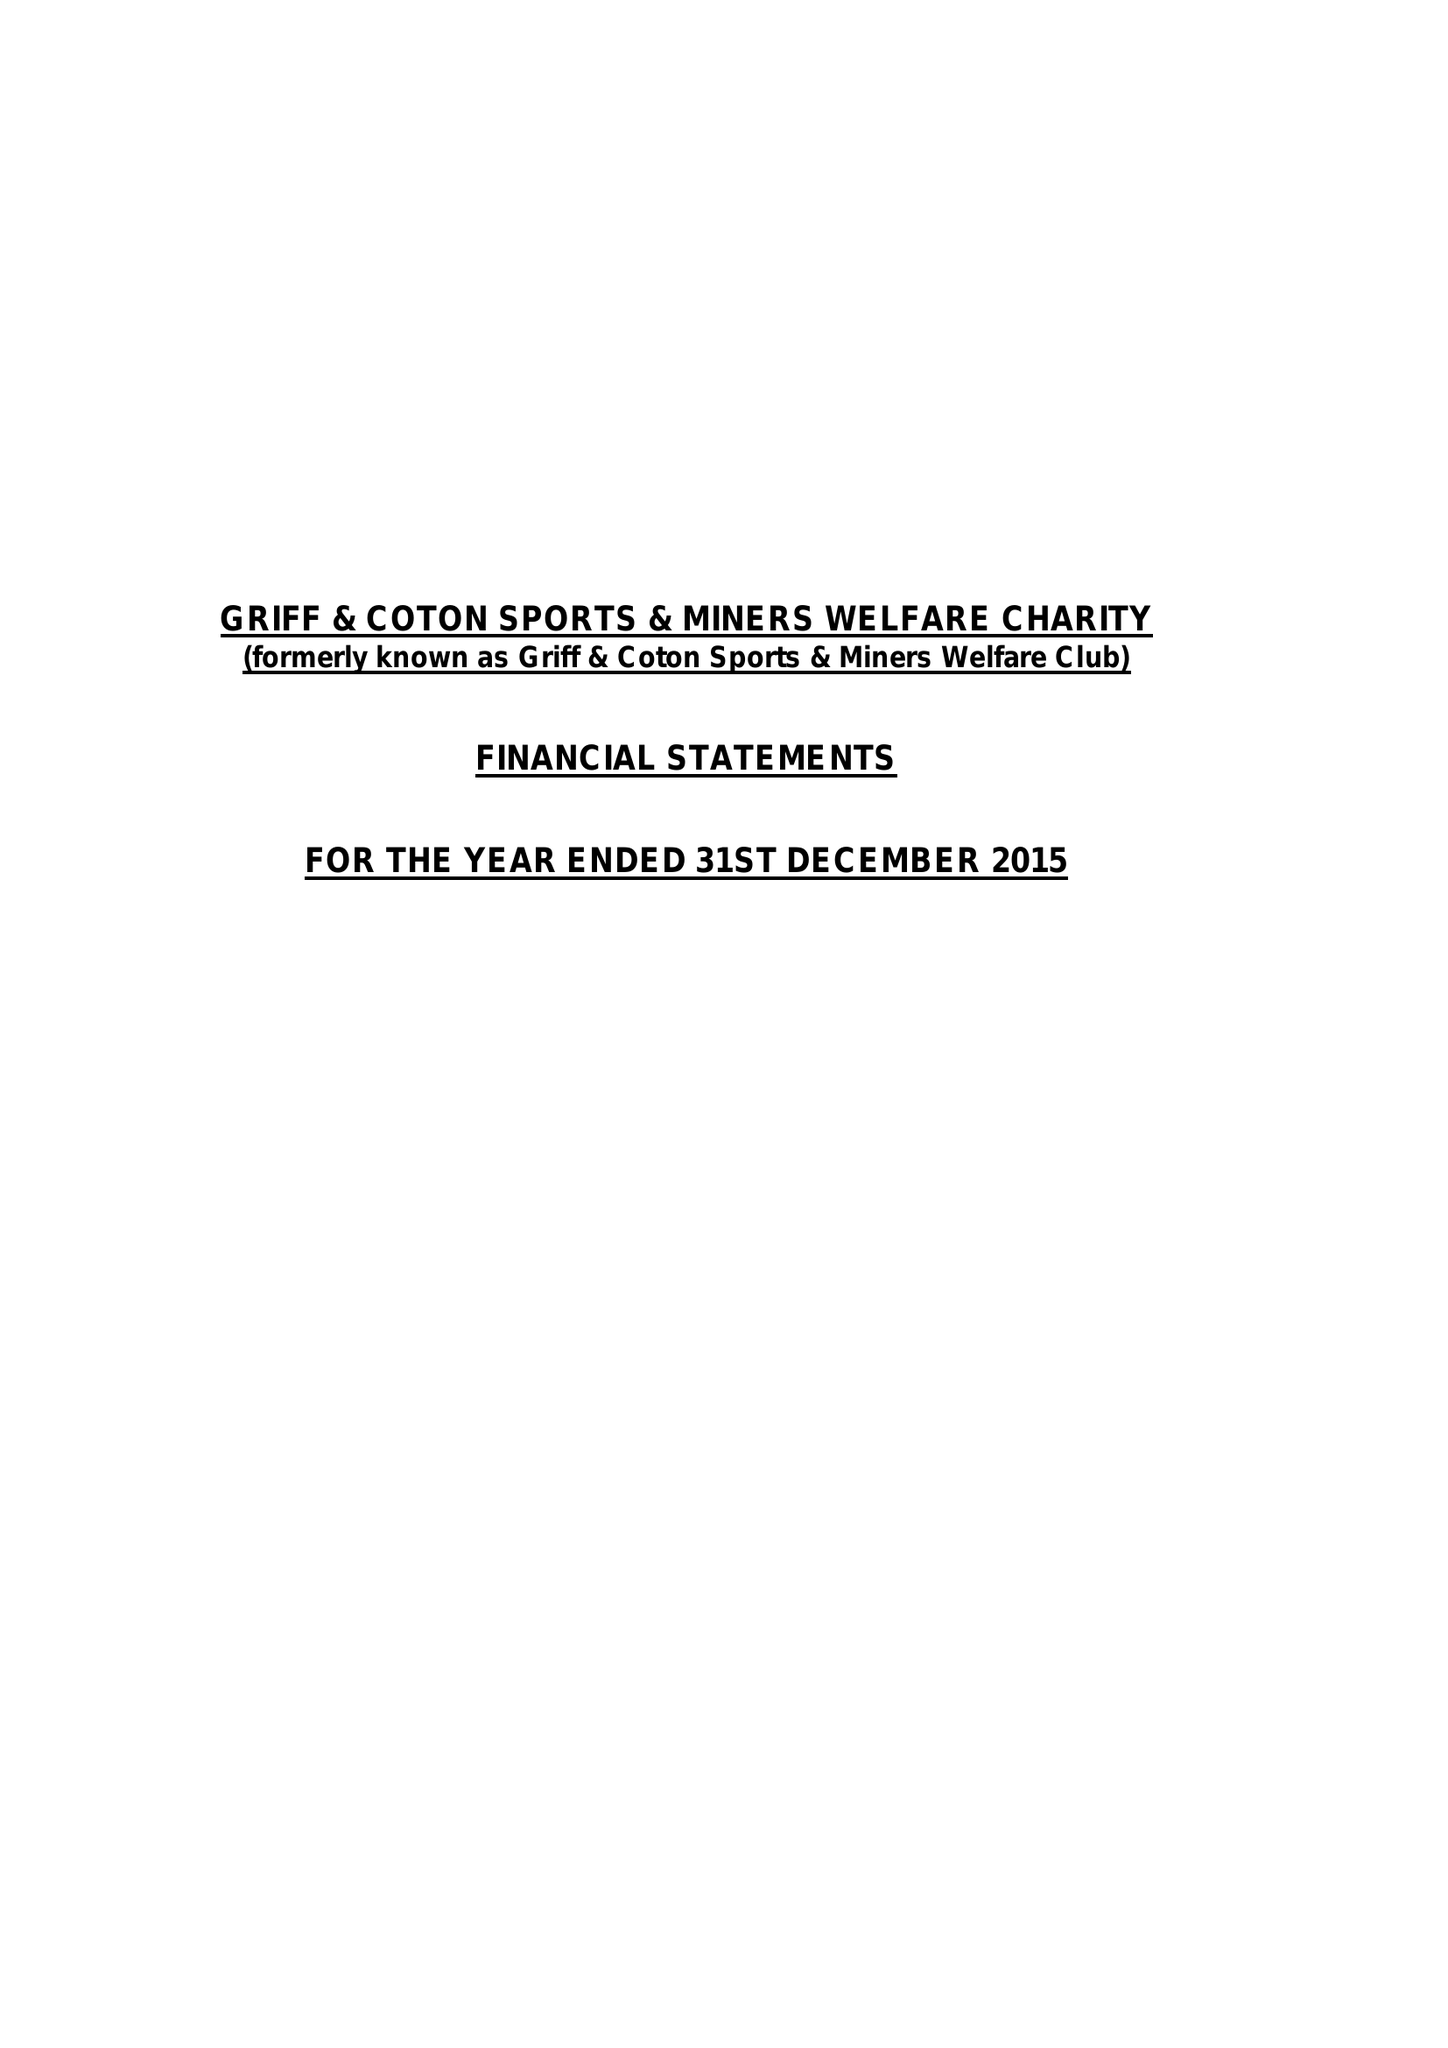What is the value for the spending_annually_in_british_pounds?
Answer the question using a single word or phrase. 147987.00 